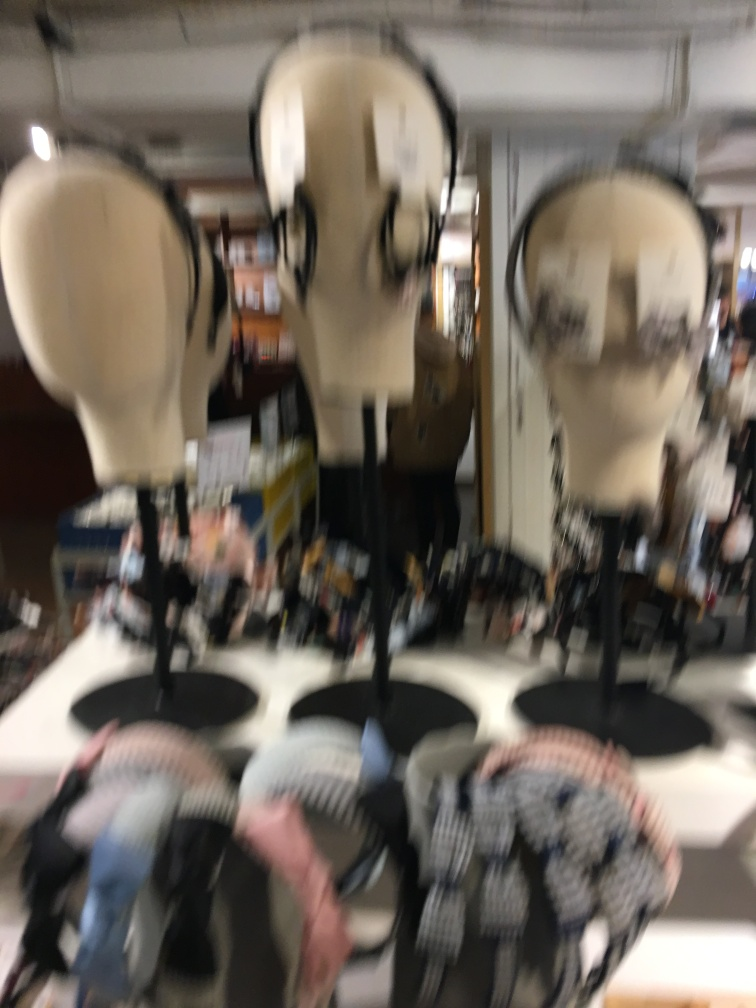Are the contours of the model clear? From the provided image, it's challenging to assess the contours of the model because the photograph is blurred. Clear visual details are necessary to discern the contours accurately. 